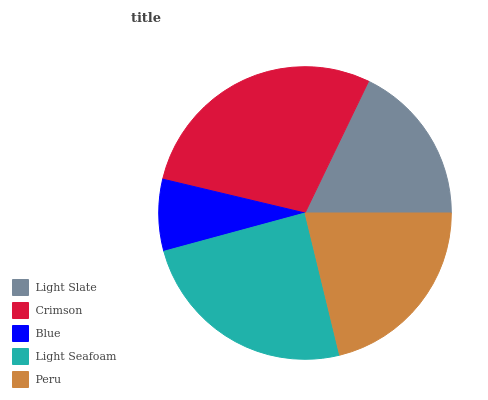Is Blue the minimum?
Answer yes or no. Yes. Is Crimson the maximum?
Answer yes or no. Yes. Is Crimson the minimum?
Answer yes or no. No. Is Blue the maximum?
Answer yes or no. No. Is Crimson greater than Blue?
Answer yes or no. Yes. Is Blue less than Crimson?
Answer yes or no. Yes. Is Blue greater than Crimson?
Answer yes or no. No. Is Crimson less than Blue?
Answer yes or no. No. Is Peru the high median?
Answer yes or no. Yes. Is Peru the low median?
Answer yes or no. Yes. Is Light Seafoam the high median?
Answer yes or no. No. Is Blue the low median?
Answer yes or no. No. 